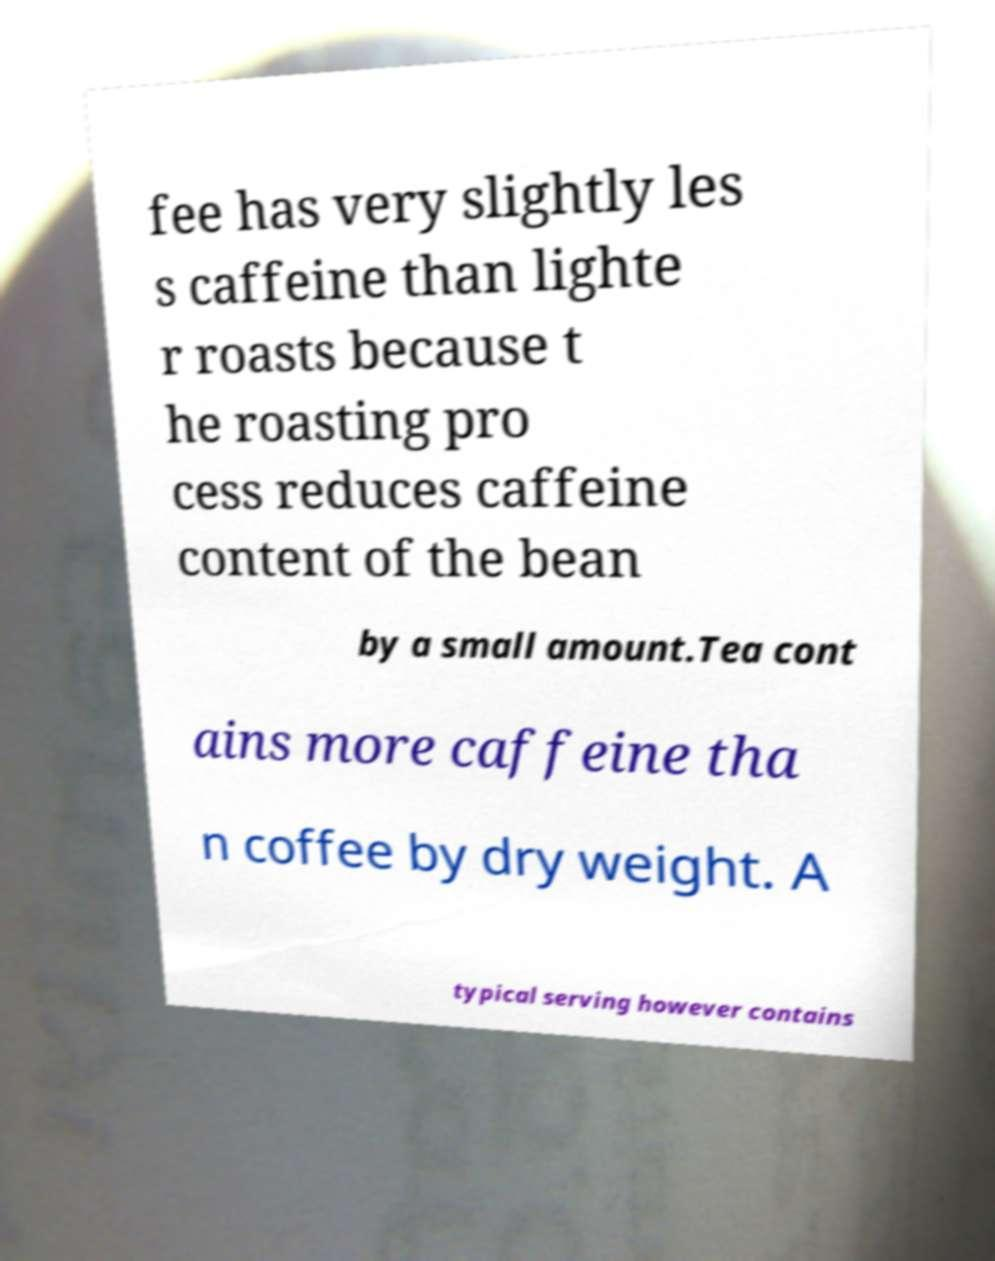Can you accurately transcribe the text from the provided image for me? fee has very slightly les s caffeine than lighte r roasts because t he roasting pro cess reduces caffeine content of the bean by a small amount.Tea cont ains more caffeine tha n coffee by dry weight. A typical serving however contains 